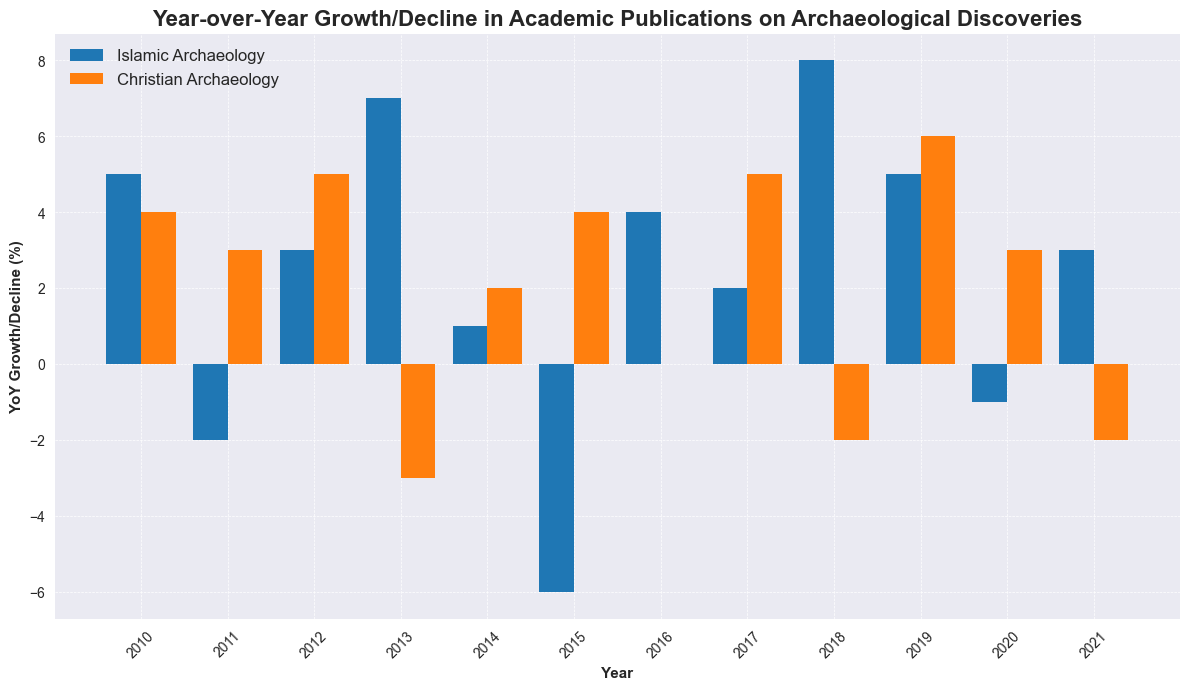Which category shows the highest year-over-year growth in publications? By looking at the bars, the highest single year-over-year growth is in Islamic Archaeology in 2018, with a value of 8.
Answer: Islamic Archaeology in 2018 Between Islamic Archaeology and Christian Archaeology, which had more years of positive growth? Islamic Archaeology had positive growth in 2010, 2012, 2013, 2014, 2016, 2017, 2018, 2019, and 2021, totaling 9 years. Christian Archaeology had positive growth in 2010, 2011, 2012, 2014, 2015, 2017, 2019, and 2020, totaling 8 years. Therefore, Islamic Archaeology had more years of positive growth.
Answer: Islamic Archaeology Which year did both categories experience a decline in publications? By checking the bars, both categories experienced a decline in 2018 for Christian Archaeology and 2015 for Islamic Archaeology, but there is no single year where both had a decline.
Answer: None In which year did Christian Archaeology experience the greatest decline in publications? By observing the bars, Christian Archaeology experienced its greatest decline in the year 2013 with a decline of 3.
Answer: 2013 What is the total year-over-year growth for Islamic Archaeology from 2010 to 2021? Sum the values for each year for Islamic Archaeology: 5 + (-2) + 3 + 7 + 1 + (-6) + 4 + 2 + 8 + 5 + (-1) + 3 = 29. Therefore, the total growth is 29.
Answer: 29 Which category had the most fluctuation in year-over-year growth? Fluctuation can be judged by the range of positive and negative values. Islamic Archaeology ranges from -6 to 8, while Christian Archaeology ranges from -3 to 6. Therefore, Islamic Archaeology had the most fluctuation.
Answer: Islamic Archaeology During which year did Islamic Archaeology have negative growth, but Christian Archaeology did not? By comparing the bars, we find that Islamic Archaeology had negative growth in 2011 and 2015, and during those years, Christian Archaeology had positive growth.
Answer: 2011 and 2015 In which years did both categories experience positive growth? Both categories experienced positive growth in the years 2010, 2012, 2014, 2017, and 2019. Observing the bars for both categories confirms these years.
Answer: 2010, 2012, 2014, 2017, 2019 